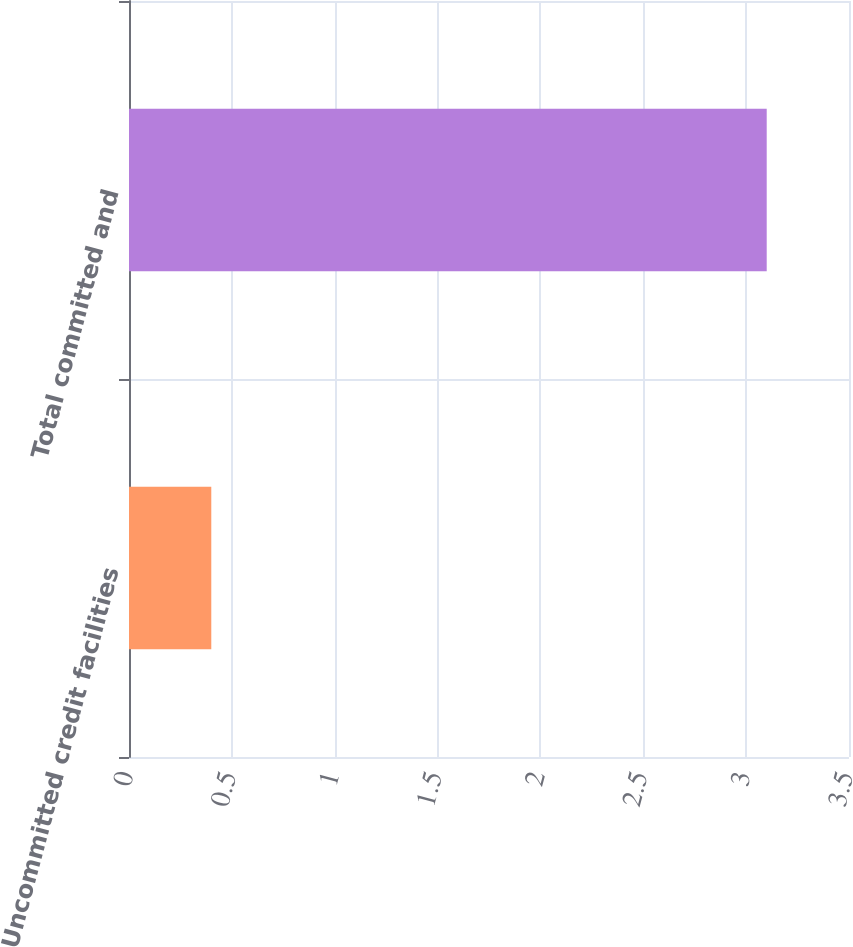Convert chart to OTSL. <chart><loc_0><loc_0><loc_500><loc_500><bar_chart><fcel>Uncommitted credit facilities<fcel>Total committed and<nl><fcel>0.4<fcel>3.1<nl></chart> 